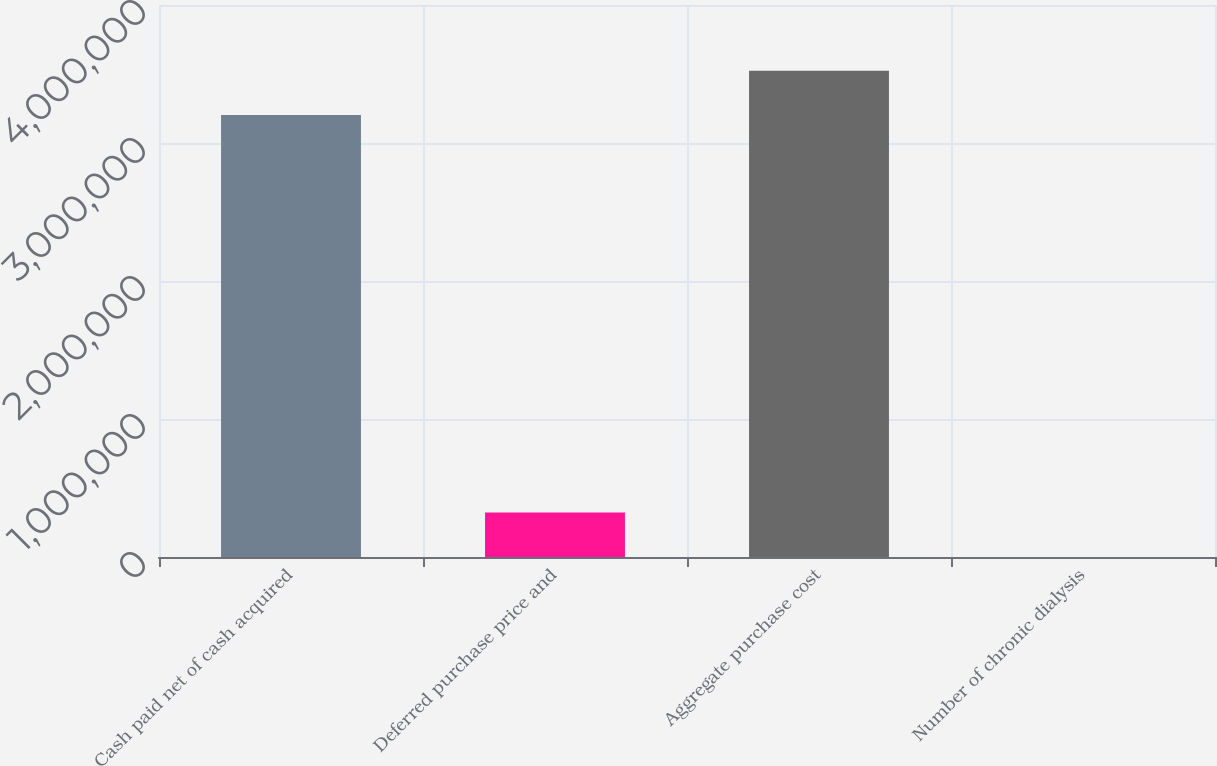Convert chart. <chart><loc_0><loc_0><loc_500><loc_500><bar_chart><fcel>Cash paid net of cash acquired<fcel>Deferred purchase price and<fcel>Aggregate purchase cost<fcel>Number of chronic dialysis<nl><fcel>3.2024e+06<fcel>321722<fcel>3.52352e+06<fcel>609<nl></chart> 